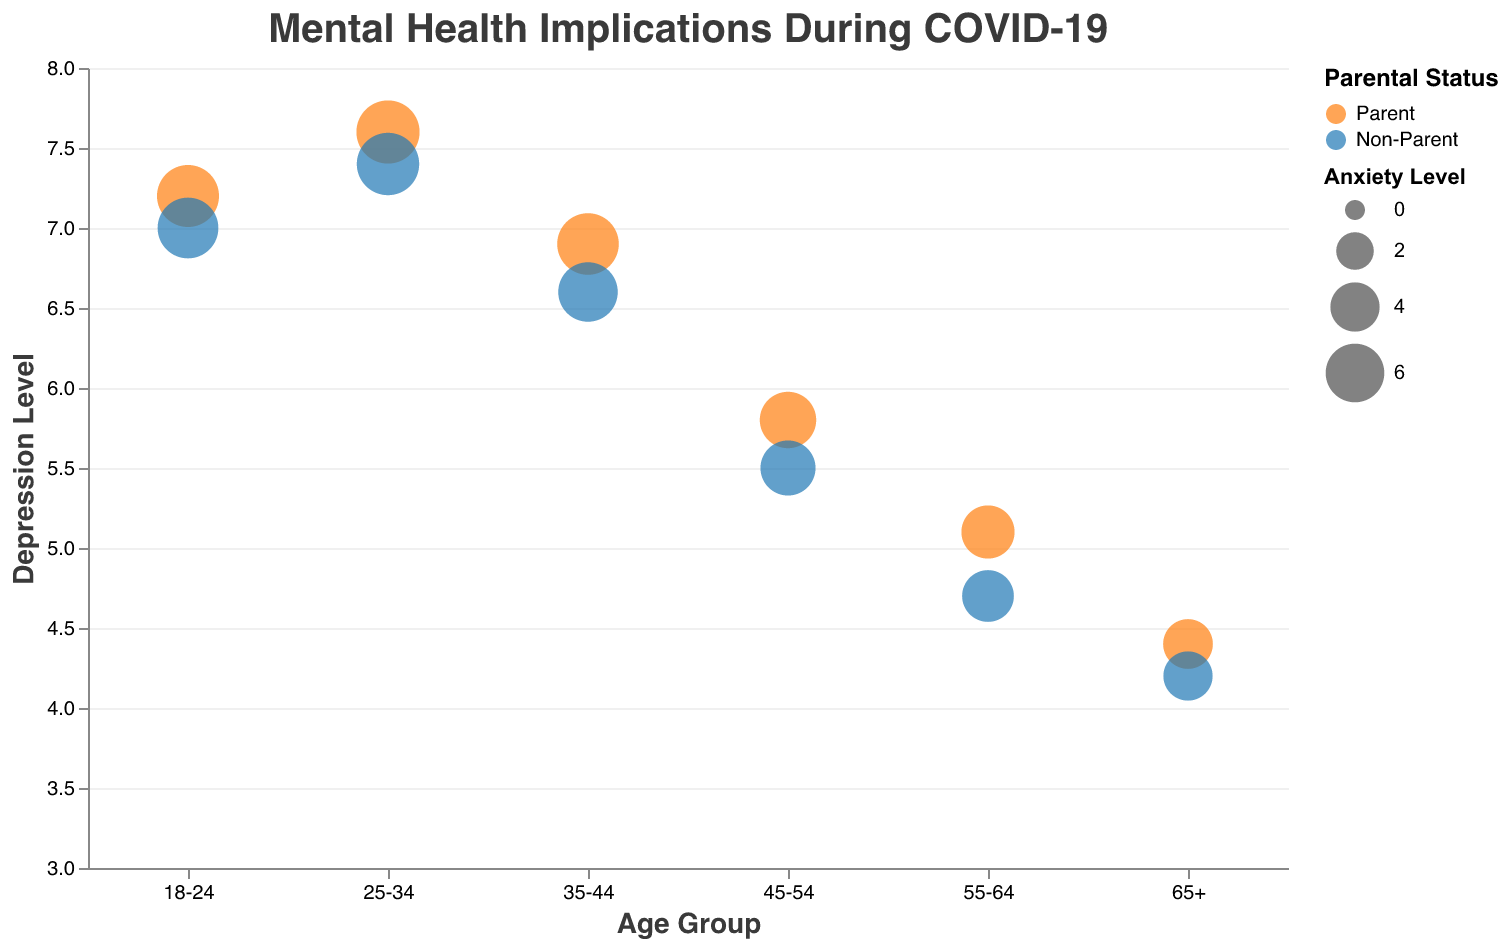What is the title of the chart? The title of the chart is written at the top in a larger font size.
Answer: Mental Health Implications During COVID-19 What is the age group with the highest depression level among parents? Observing the y-axis (Depression Level) and the chart, the highest point for the "Parent" color is at the age group 25-34.
Answer: 25-34 Which group has larger bubbles overall, parents or non-parents? The size of the bubbles represents the Anxiety Level. By comparing the bubble sizes for "Parent" and "Non-Parent" groups, it is evident that the bubbles for parents are generally larger.
Answer: Parents How does the stress level change with age among non-parents? Looking at the y-axis Stress Level for the bubbles with the color representing "Non-Parent," the stress level decreases as the age group increases.
Answer: It decreases What is the average anxiety level for parents in the age groups 18-24 and 25-34? The anxiety level for parents in these age groups is 6.8 and 7.1, respectively. Calculating the average: (6.8 + 7.1)/2 = 6.95.
Answer: 6.95 Which age group shows the highest level of isolation for non-parents? By observing the Isolation Level for non-parents, the highest point is seen at age group 25-34.
Answer: 25-34 How does the depression level of parents compare between age groups 45-54 and 55-64? Comparing the y-axis (Depression Level) values for parents in age groups 45-54 and 55-64, the depression level for 45-54 is 5.8 and for 55-64 is 5.1, so it is higher in 45-54.
Answer: It is higher in age group 45-54 Which age group has the lowest anxiety level for non-parents? The smallest bubble for non-parents, indicating the lowest anxiety level, is in the age group 65+.
Answer: 65+ What is the trend of anxiety levels among parents as they get older? Observing the bubble sizes for "Parent" color, the bubbles decrease in size from younger to older age groups, indicating that anxiety levels decrease with age.
Answer: Anxiety levels decrease In the 35-44 age group, how do the levels of stress compare for parents and non-parents? By comparing the y-axis (Stress Level) values for both "Parent" and "Non-Parent" colors in the 35-44 age group, the stress levels are 6.4 for parents and 6.1 for non-parents.
Answer: Parents have a higher stress level 